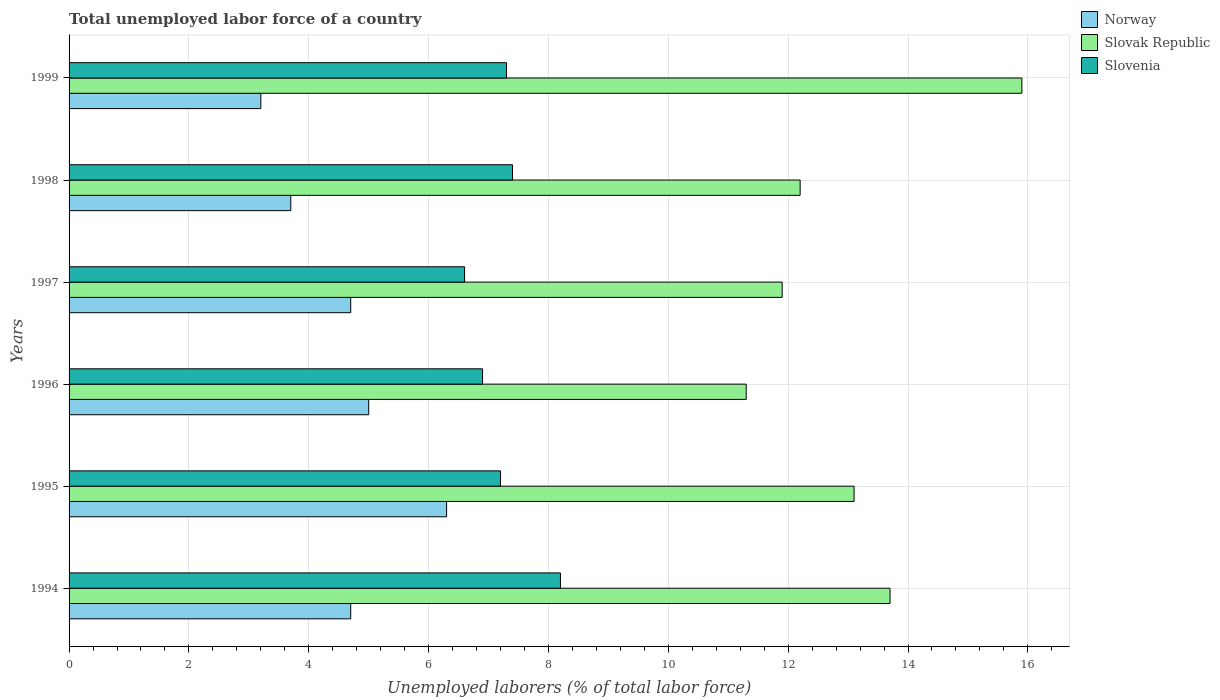How many different coloured bars are there?
Offer a very short reply. 3. How many bars are there on the 4th tick from the bottom?
Provide a succinct answer. 3. What is the label of the 2nd group of bars from the top?
Ensure brevity in your answer.  1998. What is the total unemployed labor force in Norway in 1999?
Your answer should be compact. 3.2. Across all years, what is the maximum total unemployed labor force in Slovenia?
Provide a succinct answer. 8.2. Across all years, what is the minimum total unemployed labor force in Slovenia?
Your answer should be very brief. 6.6. In which year was the total unemployed labor force in Slovak Republic maximum?
Make the answer very short. 1999. In which year was the total unemployed labor force in Slovak Republic minimum?
Your response must be concise. 1996. What is the total total unemployed labor force in Slovak Republic in the graph?
Your answer should be very brief. 78.1. What is the difference between the total unemployed labor force in Slovak Republic in 1994 and that in 1999?
Keep it short and to the point. -2.2. What is the difference between the total unemployed labor force in Norway in 1997 and the total unemployed labor force in Slovenia in 1999?
Your answer should be compact. -2.6. What is the average total unemployed labor force in Slovenia per year?
Ensure brevity in your answer.  7.27. In the year 1996, what is the difference between the total unemployed labor force in Slovenia and total unemployed labor force in Slovak Republic?
Your answer should be compact. -4.4. In how many years, is the total unemployed labor force in Slovenia greater than 5.2 %?
Offer a very short reply. 6. What is the ratio of the total unemployed labor force in Norway in 1995 to that in 1997?
Your answer should be very brief. 1.34. Is the total unemployed labor force in Norway in 1996 less than that in 1999?
Offer a terse response. No. What is the difference between the highest and the second highest total unemployed labor force in Slovenia?
Your answer should be very brief. 0.8. What is the difference between the highest and the lowest total unemployed labor force in Slovenia?
Provide a succinct answer. 1.6. In how many years, is the total unemployed labor force in Slovenia greater than the average total unemployed labor force in Slovenia taken over all years?
Make the answer very short. 3. What does the 2nd bar from the bottom in 1995 represents?
Give a very brief answer. Slovak Republic. Is it the case that in every year, the sum of the total unemployed labor force in Slovenia and total unemployed labor force in Norway is greater than the total unemployed labor force in Slovak Republic?
Your answer should be very brief. No. How many years are there in the graph?
Offer a terse response. 6. What is the difference between two consecutive major ticks on the X-axis?
Keep it short and to the point. 2. Are the values on the major ticks of X-axis written in scientific E-notation?
Give a very brief answer. No. Does the graph contain grids?
Your response must be concise. Yes. How are the legend labels stacked?
Ensure brevity in your answer.  Vertical. What is the title of the graph?
Keep it short and to the point. Total unemployed labor force of a country. What is the label or title of the X-axis?
Offer a very short reply. Unemployed laborers (% of total labor force). What is the label or title of the Y-axis?
Provide a succinct answer. Years. What is the Unemployed laborers (% of total labor force) in Norway in 1994?
Provide a short and direct response. 4.7. What is the Unemployed laborers (% of total labor force) in Slovak Republic in 1994?
Provide a short and direct response. 13.7. What is the Unemployed laborers (% of total labor force) in Slovenia in 1994?
Your answer should be very brief. 8.2. What is the Unemployed laborers (% of total labor force) in Norway in 1995?
Ensure brevity in your answer.  6.3. What is the Unemployed laborers (% of total labor force) in Slovak Republic in 1995?
Ensure brevity in your answer.  13.1. What is the Unemployed laborers (% of total labor force) of Slovenia in 1995?
Offer a terse response. 7.2. What is the Unemployed laborers (% of total labor force) in Norway in 1996?
Offer a very short reply. 5. What is the Unemployed laborers (% of total labor force) in Slovak Republic in 1996?
Offer a very short reply. 11.3. What is the Unemployed laborers (% of total labor force) in Slovenia in 1996?
Give a very brief answer. 6.9. What is the Unemployed laborers (% of total labor force) of Norway in 1997?
Your answer should be very brief. 4.7. What is the Unemployed laborers (% of total labor force) in Slovak Republic in 1997?
Make the answer very short. 11.9. What is the Unemployed laborers (% of total labor force) of Slovenia in 1997?
Provide a short and direct response. 6.6. What is the Unemployed laborers (% of total labor force) in Norway in 1998?
Your response must be concise. 3.7. What is the Unemployed laborers (% of total labor force) of Slovak Republic in 1998?
Keep it short and to the point. 12.2. What is the Unemployed laborers (% of total labor force) in Slovenia in 1998?
Your answer should be compact. 7.4. What is the Unemployed laborers (% of total labor force) in Norway in 1999?
Keep it short and to the point. 3.2. What is the Unemployed laborers (% of total labor force) of Slovak Republic in 1999?
Provide a short and direct response. 15.9. What is the Unemployed laborers (% of total labor force) in Slovenia in 1999?
Give a very brief answer. 7.3. Across all years, what is the maximum Unemployed laborers (% of total labor force) of Norway?
Give a very brief answer. 6.3. Across all years, what is the maximum Unemployed laborers (% of total labor force) in Slovak Republic?
Offer a terse response. 15.9. Across all years, what is the maximum Unemployed laborers (% of total labor force) of Slovenia?
Your answer should be compact. 8.2. Across all years, what is the minimum Unemployed laborers (% of total labor force) of Norway?
Provide a succinct answer. 3.2. Across all years, what is the minimum Unemployed laborers (% of total labor force) in Slovak Republic?
Your response must be concise. 11.3. Across all years, what is the minimum Unemployed laborers (% of total labor force) in Slovenia?
Give a very brief answer. 6.6. What is the total Unemployed laborers (% of total labor force) of Norway in the graph?
Your answer should be compact. 27.6. What is the total Unemployed laborers (% of total labor force) in Slovak Republic in the graph?
Your answer should be compact. 78.1. What is the total Unemployed laborers (% of total labor force) in Slovenia in the graph?
Make the answer very short. 43.6. What is the difference between the Unemployed laborers (% of total labor force) of Norway in 1994 and that in 1995?
Ensure brevity in your answer.  -1.6. What is the difference between the Unemployed laborers (% of total labor force) of Slovenia in 1994 and that in 1995?
Your response must be concise. 1. What is the difference between the Unemployed laborers (% of total labor force) of Norway in 1994 and that in 1996?
Offer a very short reply. -0.3. What is the difference between the Unemployed laborers (% of total labor force) in Slovak Republic in 1994 and that in 1996?
Offer a very short reply. 2.4. What is the difference between the Unemployed laborers (% of total labor force) in Norway in 1994 and that in 1997?
Offer a very short reply. 0. What is the difference between the Unemployed laborers (% of total labor force) of Slovak Republic in 1994 and that in 1997?
Provide a short and direct response. 1.8. What is the difference between the Unemployed laborers (% of total labor force) of Slovenia in 1994 and that in 1997?
Your answer should be compact. 1.6. What is the difference between the Unemployed laborers (% of total labor force) of Slovenia in 1994 and that in 1998?
Offer a very short reply. 0.8. What is the difference between the Unemployed laborers (% of total labor force) in Norway in 1994 and that in 1999?
Offer a very short reply. 1.5. What is the difference between the Unemployed laborers (% of total labor force) in Slovak Republic in 1994 and that in 1999?
Your answer should be compact. -2.2. What is the difference between the Unemployed laborers (% of total labor force) in Slovenia in 1994 and that in 1999?
Provide a succinct answer. 0.9. What is the difference between the Unemployed laborers (% of total labor force) in Slovak Republic in 1995 and that in 1996?
Keep it short and to the point. 1.8. What is the difference between the Unemployed laborers (% of total labor force) in Slovak Republic in 1995 and that in 1997?
Your answer should be compact. 1.2. What is the difference between the Unemployed laborers (% of total labor force) in Norway in 1995 and that in 1998?
Provide a short and direct response. 2.6. What is the difference between the Unemployed laborers (% of total labor force) of Slovak Republic in 1995 and that in 1998?
Your response must be concise. 0.9. What is the difference between the Unemployed laborers (% of total labor force) of Slovenia in 1995 and that in 1998?
Give a very brief answer. -0.2. What is the difference between the Unemployed laborers (% of total labor force) of Norway in 1995 and that in 1999?
Offer a very short reply. 3.1. What is the difference between the Unemployed laborers (% of total labor force) of Slovenia in 1995 and that in 1999?
Offer a terse response. -0.1. What is the difference between the Unemployed laborers (% of total labor force) in Norway in 1996 and that in 1998?
Keep it short and to the point. 1.3. What is the difference between the Unemployed laborers (% of total labor force) in Slovenia in 1996 and that in 1998?
Keep it short and to the point. -0.5. What is the difference between the Unemployed laborers (% of total labor force) of Slovak Republic in 1996 and that in 1999?
Give a very brief answer. -4.6. What is the difference between the Unemployed laborers (% of total labor force) of Norway in 1997 and that in 1998?
Keep it short and to the point. 1. What is the difference between the Unemployed laborers (% of total labor force) in Slovenia in 1997 and that in 1999?
Ensure brevity in your answer.  -0.7. What is the difference between the Unemployed laborers (% of total labor force) of Slovak Republic in 1998 and that in 1999?
Provide a succinct answer. -3.7. What is the difference between the Unemployed laborers (% of total labor force) of Norway in 1994 and the Unemployed laborers (% of total labor force) of Slovenia in 1995?
Provide a succinct answer. -2.5. What is the difference between the Unemployed laborers (% of total labor force) of Slovak Republic in 1994 and the Unemployed laborers (% of total labor force) of Slovenia in 1996?
Ensure brevity in your answer.  6.8. What is the difference between the Unemployed laborers (% of total labor force) of Slovak Republic in 1994 and the Unemployed laborers (% of total labor force) of Slovenia in 1998?
Provide a short and direct response. 6.3. What is the difference between the Unemployed laborers (% of total labor force) in Slovak Republic in 1994 and the Unemployed laborers (% of total labor force) in Slovenia in 1999?
Your answer should be very brief. 6.4. What is the difference between the Unemployed laborers (% of total labor force) of Norway in 1995 and the Unemployed laborers (% of total labor force) of Slovak Republic in 1996?
Offer a terse response. -5. What is the difference between the Unemployed laborers (% of total labor force) in Norway in 1995 and the Unemployed laborers (% of total labor force) in Slovenia in 1996?
Offer a terse response. -0.6. What is the difference between the Unemployed laborers (% of total labor force) of Norway in 1995 and the Unemployed laborers (% of total labor force) of Slovak Republic in 1997?
Your answer should be very brief. -5.6. What is the difference between the Unemployed laborers (% of total labor force) in Slovak Republic in 1995 and the Unemployed laborers (% of total labor force) in Slovenia in 1997?
Your answer should be very brief. 6.5. What is the difference between the Unemployed laborers (% of total labor force) in Norway in 1995 and the Unemployed laborers (% of total labor force) in Slovak Republic in 1998?
Offer a very short reply. -5.9. What is the difference between the Unemployed laborers (% of total labor force) of Slovak Republic in 1995 and the Unemployed laborers (% of total labor force) of Slovenia in 1998?
Make the answer very short. 5.7. What is the difference between the Unemployed laborers (% of total labor force) of Norway in 1995 and the Unemployed laborers (% of total labor force) of Slovak Republic in 1999?
Offer a terse response. -9.6. What is the difference between the Unemployed laborers (% of total labor force) of Slovak Republic in 1995 and the Unemployed laborers (% of total labor force) of Slovenia in 1999?
Make the answer very short. 5.8. What is the difference between the Unemployed laborers (% of total labor force) in Norway in 1996 and the Unemployed laborers (% of total labor force) in Slovak Republic in 1997?
Give a very brief answer. -6.9. What is the difference between the Unemployed laborers (% of total labor force) of Norway in 1996 and the Unemployed laborers (% of total labor force) of Slovenia in 1997?
Provide a short and direct response. -1.6. What is the difference between the Unemployed laborers (% of total labor force) in Slovak Republic in 1996 and the Unemployed laborers (% of total labor force) in Slovenia in 1997?
Your answer should be compact. 4.7. What is the difference between the Unemployed laborers (% of total labor force) in Norway in 1996 and the Unemployed laborers (% of total labor force) in Slovak Republic in 1998?
Your response must be concise. -7.2. What is the difference between the Unemployed laborers (% of total labor force) of Norway in 1996 and the Unemployed laborers (% of total labor force) of Slovenia in 1998?
Offer a terse response. -2.4. What is the difference between the Unemployed laborers (% of total labor force) in Slovak Republic in 1996 and the Unemployed laborers (% of total labor force) in Slovenia in 1998?
Give a very brief answer. 3.9. What is the difference between the Unemployed laborers (% of total labor force) of Slovak Republic in 1996 and the Unemployed laborers (% of total labor force) of Slovenia in 1999?
Keep it short and to the point. 4. What is the difference between the Unemployed laborers (% of total labor force) of Norway in 1997 and the Unemployed laborers (% of total labor force) of Slovak Republic in 1998?
Your answer should be compact. -7.5. What is the difference between the Unemployed laborers (% of total labor force) of Norway in 1997 and the Unemployed laborers (% of total labor force) of Slovak Republic in 1999?
Your answer should be compact. -11.2. What is the difference between the Unemployed laborers (% of total labor force) in Norway in 1998 and the Unemployed laborers (% of total labor force) in Slovak Republic in 1999?
Ensure brevity in your answer.  -12.2. What is the difference between the Unemployed laborers (% of total labor force) in Norway in 1998 and the Unemployed laborers (% of total labor force) in Slovenia in 1999?
Give a very brief answer. -3.6. What is the difference between the Unemployed laborers (% of total labor force) in Slovak Republic in 1998 and the Unemployed laborers (% of total labor force) in Slovenia in 1999?
Provide a short and direct response. 4.9. What is the average Unemployed laborers (% of total labor force) of Slovak Republic per year?
Your answer should be compact. 13.02. What is the average Unemployed laborers (% of total labor force) of Slovenia per year?
Your answer should be very brief. 7.27. In the year 1994, what is the difference between the Unemployed laborers (% of total labor force) in Norway and Unemployed laborers (% of total labor force) in Slovak Republic?
Make the answer very short. -9. In the year 1994, what is the difference between the Unemployed laborers (% of total labor force) in Norway and Unemployed laborers (% of total labor force) in Slovenia?
Keep it short and to the point. -3.5. In the year 1994, what is the difference between the Unemployed laborers (% of total labor force) of Slovak Republic and Unemployed laborers (% of total labor force) of Slovenia?
Give a very brief answer. 5.5. In the year 1995, what is the difference between the Unemployed laborers (% of total labor force) in Norway and Unemployed laborers (% of total labor force) in Slovak Republic?
Your answer should be compact. -6.8. In the year 1995, what is the difference between the Unemployed laborers (% of total labor force) in Norway and Unemployed laborers (% of total labor force) in Slovenia?
Your answer should be very brief. -0.9. In the year 1996, what is the difference between the Unemployed laborers (% of total labor force) of Norway and Unemployed laborers (% of total labor force) of Slovenia?
Your response must be concise. -1.9. In the year 1996, what is the difference between the Unemployed laborers (% of total labor force) of Slovak Republic and Unemployed laborers (% of total labor force) of Slovenia?
Offer a terse response. 4.4. In the year 1997, what is the difference between the Unemployed laborers (% of total labor force) in Norway and Unemployed laborers (% of total labor force) in Slovenia?
Keep it short and to the point. -1.9. In the year 1997, what is the difference between the Unemployed laborers (% of total labor force) in Slovak Republic and Unemployed laborers (% of total labor force) in Slovenia?
Your response must be concise. 5.3. What is the ratio of the Unemployed laborers (% of total labor force) of Norway in 1994 to that in 1995?
Your answer should be very brief. 0.75. What is the ratio of the Unemployed laborers (% of total labor force) in Slovak Republic in 1994 to that in 1995?
Provide a succinct answer. 1.05. What is the ratio of the Unemployed laborers (% of total labor force) of Slovenia in 1994 to that in 1995?
Give a very brief answer. 1.14. What is the ratio of the Unemployed laborers (% of total labor force) in Norway in 1994 to that in 1996?
Provide a short and direct response. 0.94. What is the ratio of the Unemployed laborers (% of total labor force) of Slovak Republic in 1994 to that in 1996?
Provide a succinct answer. 1.21. What is the ratio of the Unemployed laborers (% of total labor force) in Slovenia in 1994 to that in 1996?
Provide a succinct answer. 1.19. What is the ratio of the Unemployed laborers (% of total labor force) of Slovak Republic in 1994 to that in 1997?
Offer a very short reply. 1.15. What is the ratio of the Unemployed laborers (% of total labor force) in Slovenia in 1994 to that in 1997?
Give a very brief answer. 1.24. What is the ratio of the Unemployed laborers (% of total labor force) of Norway in 1994 to that in 1998?
Provide a short and direct response. 1.27. What is the ratio of the Unemployed laborers (% of total labor force) of Slovak Republic in 1994 to that in 1998?
Offer a very short reply. 1.12. What is the ratio of the Unemployed laborers (% of total labor force) in Slovenia in 1994 to that in 1998?
Make the answer very short. 1.11. What is the ratio of the Unemployed laborers (% of total labor force) in Norway in 1994 to that in 1999?
Offer a terse response. 1.47. What is the ratio of the Unemployed laborers (% of total labor force) in Slovak Republic in 1994 to that in 1999?
Offer a very short reply. 0.86. What is the ratio of the Unemployed laborers (% of total labor force) of Slovenia in 1994 to that in 1999?
Your answer should be compact. 1.12. What is the ratio of the Unemployed laborers (% of total labor force) of Norway in 1995 to that in 1996?
Make the answer very short. 1.26. What is the ratio of the Unemployed laborers (% of total labor force) of Slovak Republic in 1995 to that in 1996?
Keep it short and to the point. 1.16. What is the ratio of the Unemployed laborers (% of total labor force) of Slovenia in 1995 to that in 1996?
Ensure brevity in your answer.  1.04. What is the ratio of the Unemployed laborers (% of total labor force) in Norway in 1995 to that in 1997?
Provide a short and direct response. 1.34. What is the ratio of the Unemployed laborers (% of total labor force) in Slovak Republic in 1995 to that in 1997?
Your answer should be compact. 1.1. What is the ratio of the Unemployed laborers (% of total labor force) in Norway in 1995 to that in 1998?
Your answer should be compact. 1.7. What is the ratio of the Unemployed laborers (% of total labor force) of Slovak Republic in 1995 to that in 1998?
Offer a very short reply. 1.07. What is the ratio of the Unemployed laborers (% of total labor force) in Norway in 1995 to that in 1999?
Offer a very short reply. 1.97. What is the ratio of the Unemployed laborers (% of total labor force) of Slovak Republic in 1995 to that in 1999?
Give a very brief answer. 0.82. What is the ratio of the Unemployed laborers (% of total labor force) in Slovenia in 1995 to that in 1999?
Provide a short and direct response. 0.99. What is the ratio of the Unemployed laborers (% of total labor force) of Norway in 1996 to that in 1997?
Make the answer very short. 1.06. What is the ratio of the Unemployed laborers (% of total labor force) in Slovak Republic in 1996 to that in 1997?
Provide a succinct answer. 0.95. What is the ratio of the Unemployed laborers (% of total labor force) of Slovenia in 1996 to that in 1997?
Provide a succinct answer. 1.05. What is the ratio of the Unemployed laborers (% of total labor force) in Norway in 1996 to that in 1998?
Keep it short and to the point. 1.35. What is the ratio of the Unemployed laborers (% of total labor force) of Slovak Republic in 1996 to that in 1998?
Give a very brief answer. 0.93. What is the ratio of the Unemployed laborers (% of total labor force) of Slovenia in 1996 to that in 1998?
Offer a very short reply. 0.93. What is the ratio of the Unemployed laborers (% of total labor force) of Norway in 1996 to that in 1999?
Give a very brief answer. 1.56. What is the ratio of the Unemployed laborers (% of total labor force) of Slovak Republic in 1996 to that in 1999?
Ensure brevity in your answer.  0.71. What is the ratio of the Unemployed laborers (% of total labor force) in Slovenia in 1996 to that in 1999?
Your answer should be compact. 0.95. What is the ratio of the Unemployed laborers (% of total labor force) in Norway in 1997 to that in 1998?
Your answer should be very brief. 1.27. What is the ratio of the Unemployed laborers (% of total labor force) of Slovak Republic in 1997 to that in 1998?
Give a very brief answer. 0.98. What is the ratio of the Unemployed laborers (% of total labor force) in Slovenia in 1997 to that in 1998?
Your answer should be compact. 0.89. What is the ratio of the Unemployed laborers (% of total labor force) in Norway in 1997 to that in 1999?
Give a very brief answer. 1.47. What is the ratio of the Unemployed laborers (% of total labor force) of Slovak Republic in 1997 to that in 1999?
Your answer should be very brief. 0.75. What is the ratio of the Unemployed laborers (% of total labor force) of Slovenia in 1997 to that in 1999?
Ensure brevity in your answer.  0.9. What is the ratio of the Unemployed laborers (% of total labor force) of Norway in 1998 to that in 1999?
Provide a succinct answer. 1.16. What is the ratio of the Unemployed laborers (% of total labor force) of Slovak Republic in 1998 to that in 1999?
Your response must be concise. 0.77. What is the ratio of the Unemployed laborers (% of total labor force) of Slovenia in 1998 to that in 1999?
Your answer should be compact. 1.01. What is the difference between the highest and the second highest Unemployed laborers (% of total labor force) of Norway?
Ensure brevity in your answer.  1.3. What is the difference between the highest and the second highest Unemployed laborers (% of total labor force) in Slovenia?
Make the answer very short. 0.8. What is the difference between the highest and the lowest Unemployed laborers (% of total labor force) of Slovak Republic?
Your response must be concise. 4.6. What is the difference between the highest and the lowest Unemployed laborers (% of total labor force) of Slovenia?
Offer a very short reply. 1.6. 